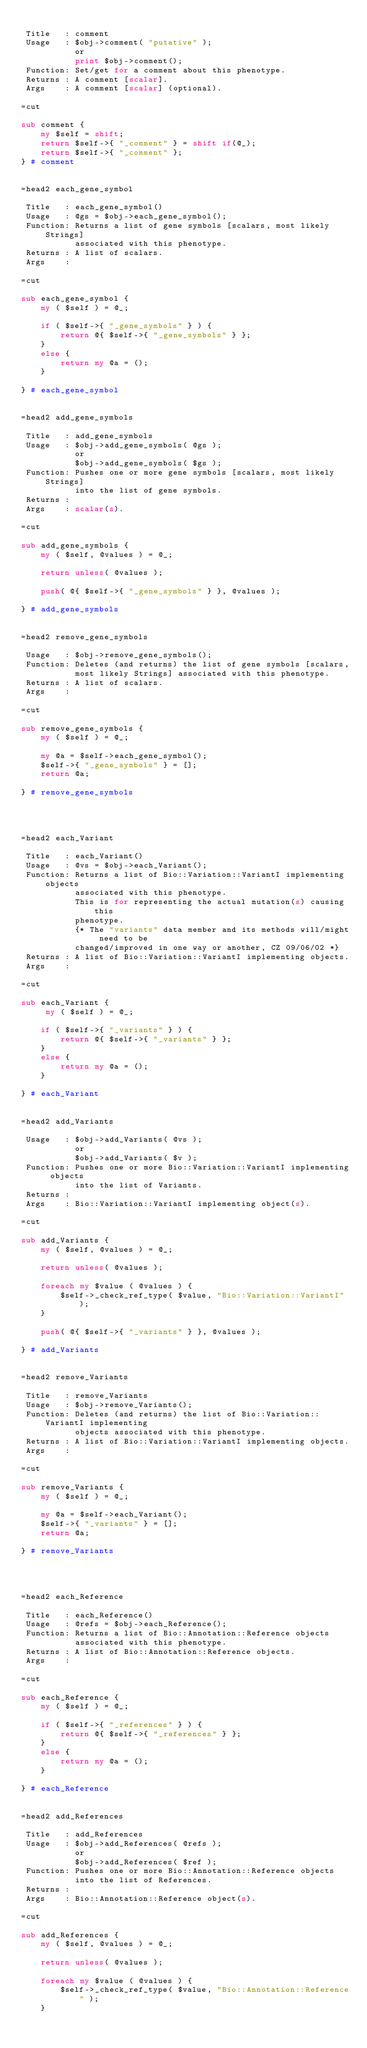<code> <loc_0><loc_0><loc_500><loc_500><_Perl_>
 Title   : comment
 Usage   : $obj->comment( "putative" );
           or
           print $obj->comment();
 Function: Set/get for a comment about this phenotype.
 Returns : A comment [scalar].
 Args    : A comment [scalar] (optional).

=cut

sub comment {
    my $self = shift;
    return $self->{ "_comment" } = shift if(@_);
    return $self->{ "_comment" };
} # comment


=head2 each_gene_symbol

 Title   : each_gene_symbol()
 Usage   : @gs = $obj->each_gene_symbol();
 Function: Returns a list of gene symbols [scalars, most likely Strings]
           associated with this phenotype.
 Returns : A list of scalars.
 Args    :

=cut

sub each_gene_symbol {
    my ( $self ) = @_;

    if ( $self->{ "_gene_symbols" } ) {
        return @{ $self->{ "_gene_symbols" } };
    }
    else {
        return my @a = (); 
    }

} # each_gene_symbol


=head2 add_gene_symbols

 Title   : add_gene_symbols
 Usage   : $obj->add_gene_symbols( @gs );
           or
           $obj->add_gene_symbols( $gs );
 Function: Pushes one or more gene symbols [scalars, most likely Strings]
           into the list of gene symbols.
 Returns : 
 Args    : scalar(s).

=cut

sub add_gene_symbols {
    my ( $self, @values ) = @_;

    return unless( @values );

    push( @{ $self->{ "_gene_symbols" } }, @values );

} # add_gene_symbols


=head2 remove_gene_symbols

 Usage   : $obj->remove_gene_symbols();
 Function: Deletes (and returns) the list of gene symbols [scalars,
           most likely Strings] associated with this phenotype.
 Returns : A list of scalars.
 Args    :

=cut

sub remove_gene_symbols {
    my ( $self ) = @_;

    my @a = $self->each_gene_symbol();
    $self->{ "_gene_symbols" } = [];
    return @a;

} # remove_gene_symbols




=head2 each_Variant

 Title   : each_Variant()
 Usage   : @vs = $obj->each_Variant();
 Function: Returns a list of Bio::Variation::VariantI implementing objects
           associated with this phenotype.
           This is for representing the actual mutation(s) causing this 
           phenotype.
           {* The "variants" data member and its methods will/might need to be
           changed/improved in one way or another, CZ 09/06/02 *}
 Returns : A list of Bio::Variation::VariantI implementing objects.
 Args    :

=cut

sub each_Variant {
     my ( $self ) = @_;

    if ( $self->{ "_variants" } ) {
        return @{ $self->{ "_variants" } };
    }
    else {
        return my @a = (); 
    }

} # each_Variant


=head2 add_Variants

 Usage   : $obj->add_Variants( @vs );
           or
           $obj->add_Variants( $v );
 Function: Pushes one or more Bio::Variation::VariantI implementing objects
           into the list of Variants.
 Returns : 
 Args    : Bio::Variation::VariantI implementing object(s).

=cut

sub add_Variants {
    my ( $self, @values ) = @_;

    return unless( @values );

    foreach my $value ( @values ) {  
        $self->_check_ref_type( $value, "Bio::Variation::VariantI" );
    }

    push( @{ $self->{ "_variants" } }, @values );

} # add_Variants


=head2 remove_Variants

 Title   : remove_Variants
 Usage   : $obj->remove_Variants();
 Function: Deletes (and returns) the list of Bio::Variation::VariantI implementing
           objects associated with this phenotype.
 Returns : A list of Bio::Variation::VariantI implementing objects.
 Args    :

=cut

sub remove_Variants {
    my ( $self ) = @_;
  
    my @a = $self->each_Variant();
    $self->{ "_variants" } = [];
    return @a;

} # remove_Variants




=head2 each_Reference

 Title   : each_Reference()
 Usage   : @refs = $obj->each_Reference();                 
 Function: Returns a list of Bio::Annotation::Reference objects
           associated with this phenotype.
 Returns : A list of Bio::Annotation::Reference objects.
 Args    :

=cut

sub each_Reference {
    my ( $self ) = @_;
    
    if ( $self->{ "_references" } ) {
        return @{ $self->{ "_references" } };
    }
    else {
        return my @a = (); 
    }

} # each_Reference


=head2 add_References 

 Title   : add_References
 Usage   : $obj->add_References( @refs );
           or
           $obj->add_References( $ref );                  
 Function: Pushes one or more Bio::Annotation::Reference objects
           into the list of References.
 Returns : 
 Args    : Bio::Annotation::Reference object(s).

=cut

sub add_References {
    my ( $self, @values ) = @_;

    return unless( @values );

    foreach my $value ( @values ) {  
        $self->_check_ref_type( $value, "Bio::Annotation::Reference" );
    }</code> 